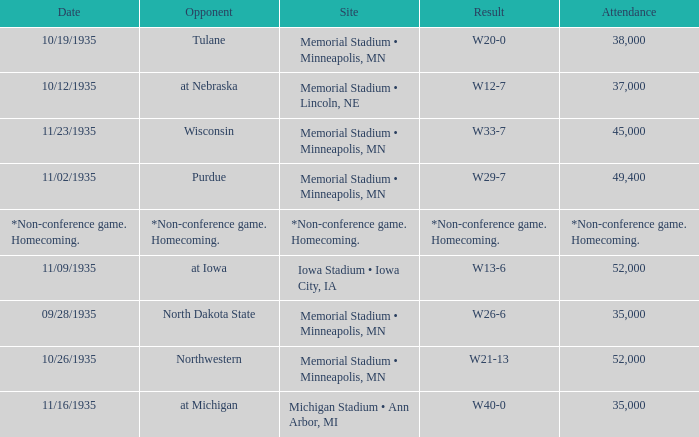How many spectators attended the game that ended in a result of w29-7? 49400.0. 